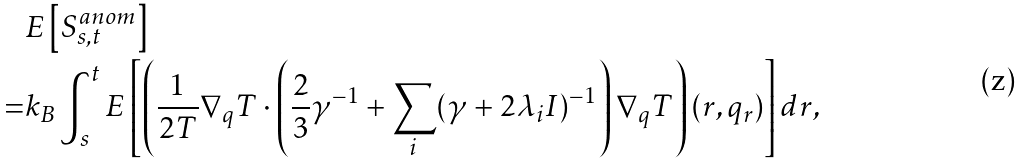<formula> <loc_0><loc_0><loc_500><loc_500>& E \left [ S _ { s , t } ^ { a n o m } \right ] \\ = & k _ { B } \int _ { s } ^ { t } E \left [ \left ( \frac { 1 } { 2 T } \nabla _ { q } T \cdot \left ( \frac { 2 } { 3 } \gamma ^ { - 1 } + \sum _ { i } ( \gamma + 2 \lambda _ { i } I ) ^ { - 1 } \right ) \nabla _ { q } T \right ) ( r , q _ { r } ) \right ] d r ,</formula> 